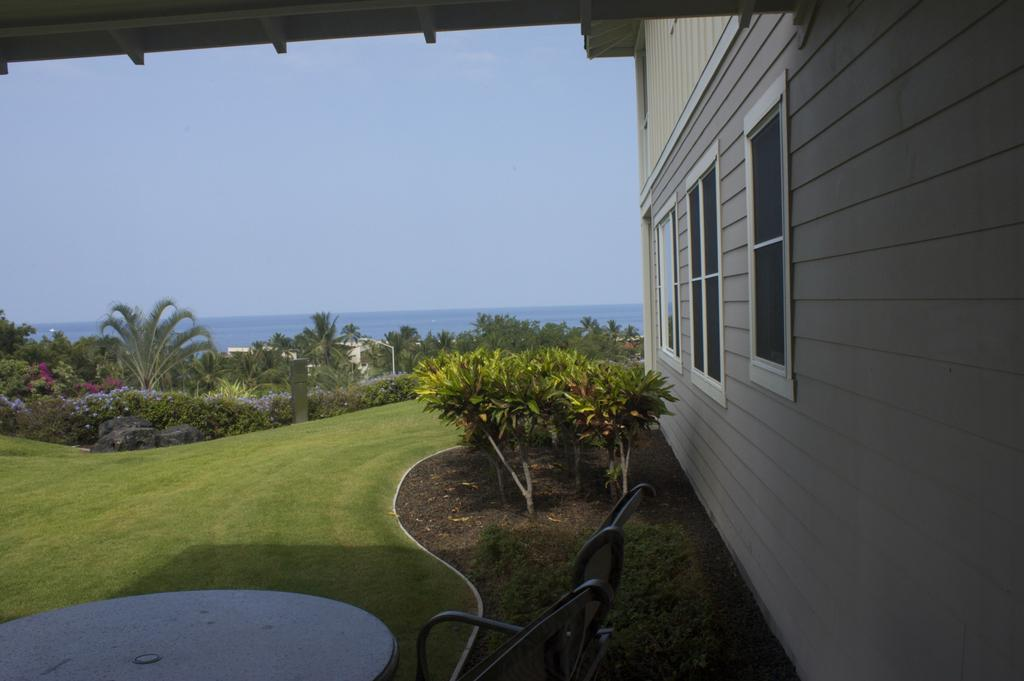What type of furniture is present in the image? There is a table in the image. What type of structure can be seen in the image? There is a building with windows in the image. What type of vegetation is present in the image? There are trees and grass in the image. What is visible in the background of the image? The sky is visible in the background of the image. Can you see any cobwebs hanging from the trees in the image? There is no mention of cobwebs in the image, so we cannot determine if they are present or not. How many stars can be seen in the sky in the image? The sky is visible in the background of the image, but there is no mention of stars, so we cannot determine how many, if any, are present. 